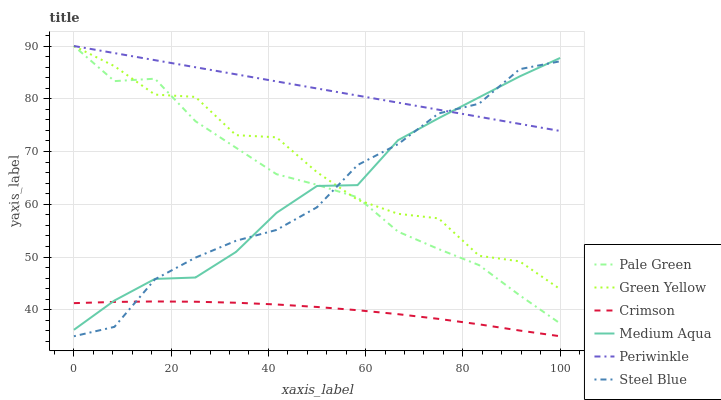Does Crimson have the minimum area under the curve?
Answer yes or no. Yes. Does Periwinkle have the maximum area under the curve?
Answer yes or no. Yes. Does Pale Green have the minimum area under the curve?
Answer yes or no. No. Does Pale Green have the maximum area under the curve?
Answer yes or no. No. Is Periwinkle the smoothest?
Answer yes or no. Yes. Is Green Yellow the roughest?
Answer yes or no. Yes. Is Pale Green the smoothest?
Answer yes or no. No. Is Pale Green the roughest?
Answer yes or no. No. Does Steel Blue have the lowest value?
Answer yes or no. Yes. Does Pale Green have the lowest value?
Answer yes or no. No. Does Green Yellow have the highest value?
Answer yes or no. Yes. Does Crimson have the highest value?
Answer yes or no. No. Is Crimson less than Pale Green?
Answer yes or no. Yes. Is Pale Green greater than Crimson?
Answer yes or no. Yes. Does Medium Aqua intersect Green Yellow?
Answer yes or no. Yes. Is Medium Aqua less than Green Yellow?
Answer yes or no. No. Is Medium Aqua greater than Green Yellow?
Answer yes or no. No. Does Crimson intersect Pale Green?
Answer yes or no. No. 